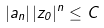Convert formula to latex. <formula><loc_0><loc_0><loc_500><loc_500>| a _ { n } | \, | z _ { 0 } | ^ { n } \leq C</formula> 